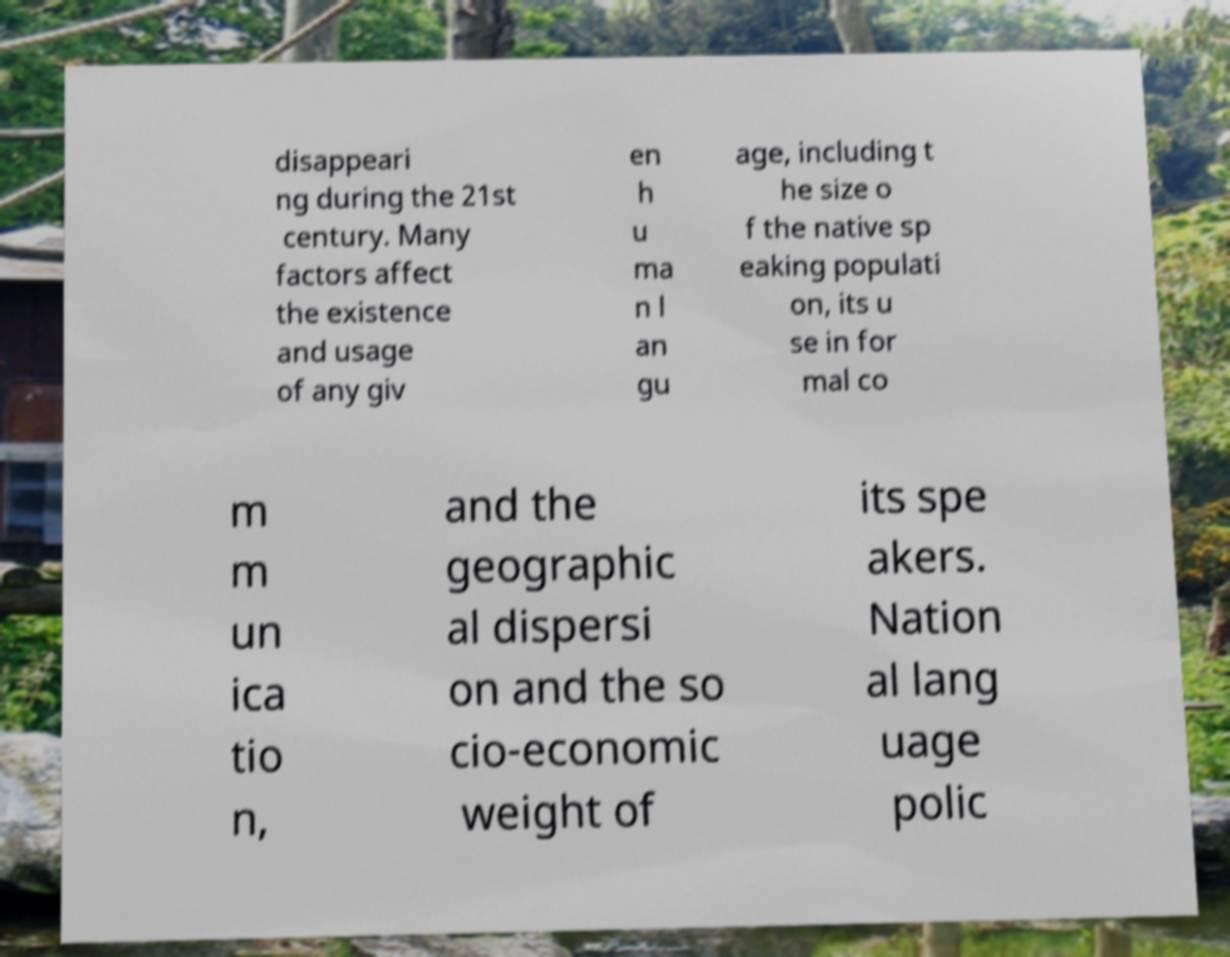Please identify and transcribe the text found in this image. disappeari ng during the 21st century. Many factors affect the existence and usage of any giv en h u ma n l an gu age, including t he size o f the native sp eaking populati on, its u se in for mal co m m un ica tio n, and the geographic al dispersi on and the so cio-economic weight of its spe akers. Nation al lang uage polic 